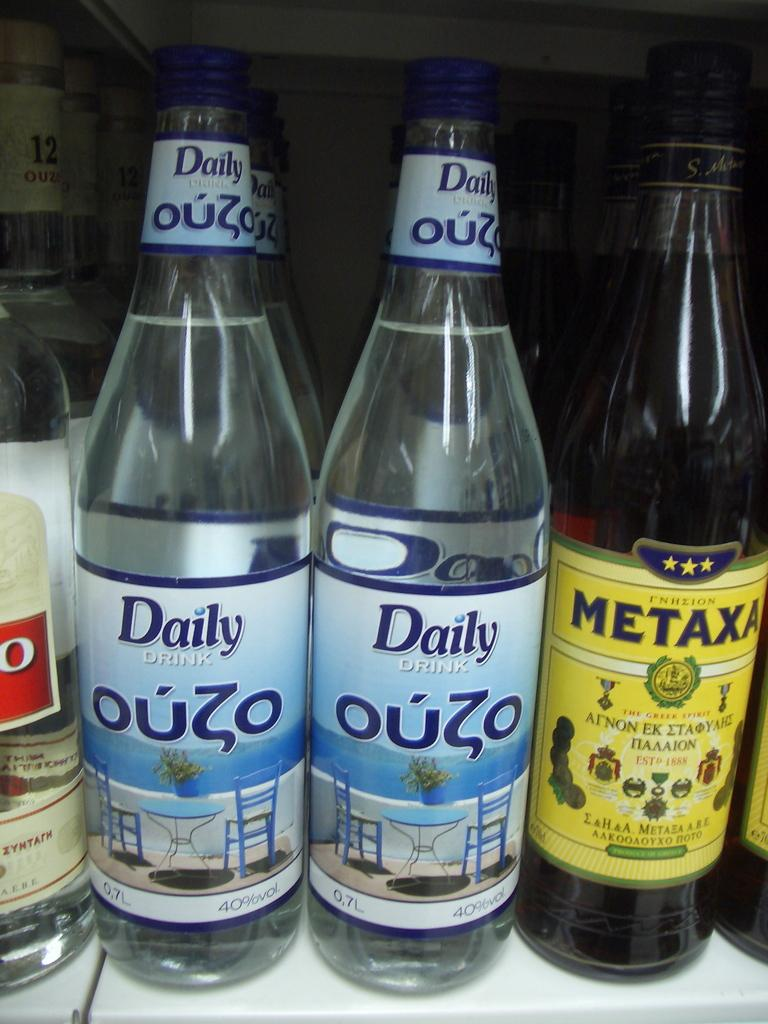<image>
Describe the image concisely. The shelf contains bottles of liquor including Daily Ouzo and Metaxa. 